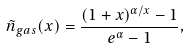Convert formula to latex. <formula><loc_0><loc_0><loc_500><loc_500>\tilde { n } _ { g a s } ( x ) = \frac { ( 1 + x ) ^ { \alpha / x } - 1 } { e ^ { \alpha } - 1 } ,</formula> 